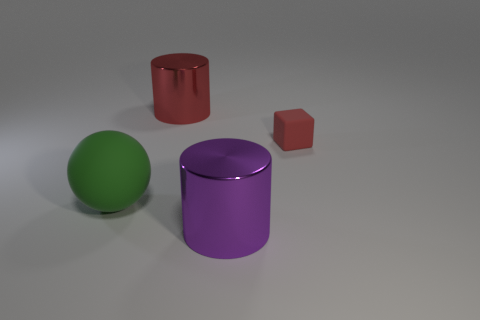Add 1 big red metal cylinders. How many objects exist? 5 Subtract all spheres. How many objects are left? 3 Add 2 tiny yellow cylinders. How many tiny yellow cylinders exist? 2 Subtract 0 yellow spheres. How many objects are left? 4 Subtract all green matte balls. Subtract all big red metal objects. How many objects are left? 2 Add 4 big purple objects. How many big purple objects are left? 5 